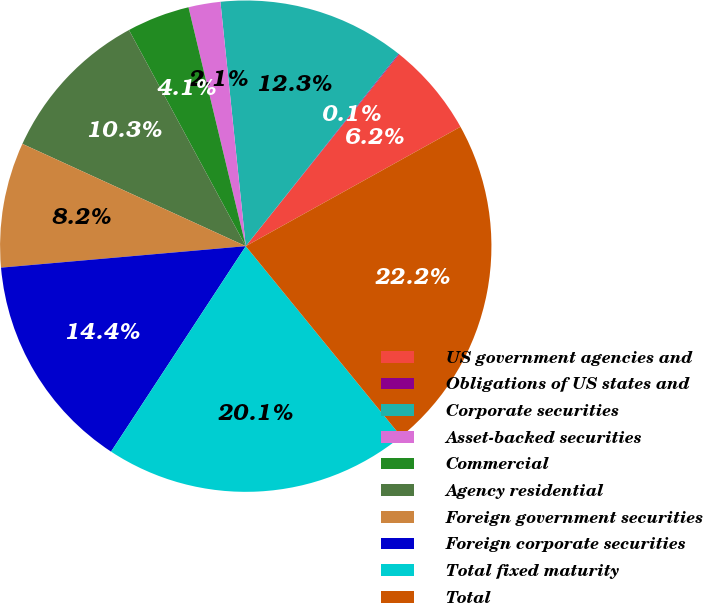Convert chart. <chart><loc_0><loc_0><loc_500><loc_500><pie_chart><fcel>US government agencies and<fcel>Obligations of US states and<fcel>Corporate securities<fcel>Asset-backed securities<fcel>Commercial<fcel>Agency residential<fcel>Foreign government securities<fcel>Foreign corporate securities<fcel>Total fixed maturity<fcel>Total<nl><fcel>6.19%<fcel>0.05%<fcel>12.33%<fcel>2.1%<fcel>4.14%<fcel>10.28%<fcel>8.23%<fcel>14.37%<fcel>20.13%<fcel>22.18%<nl></chart> 